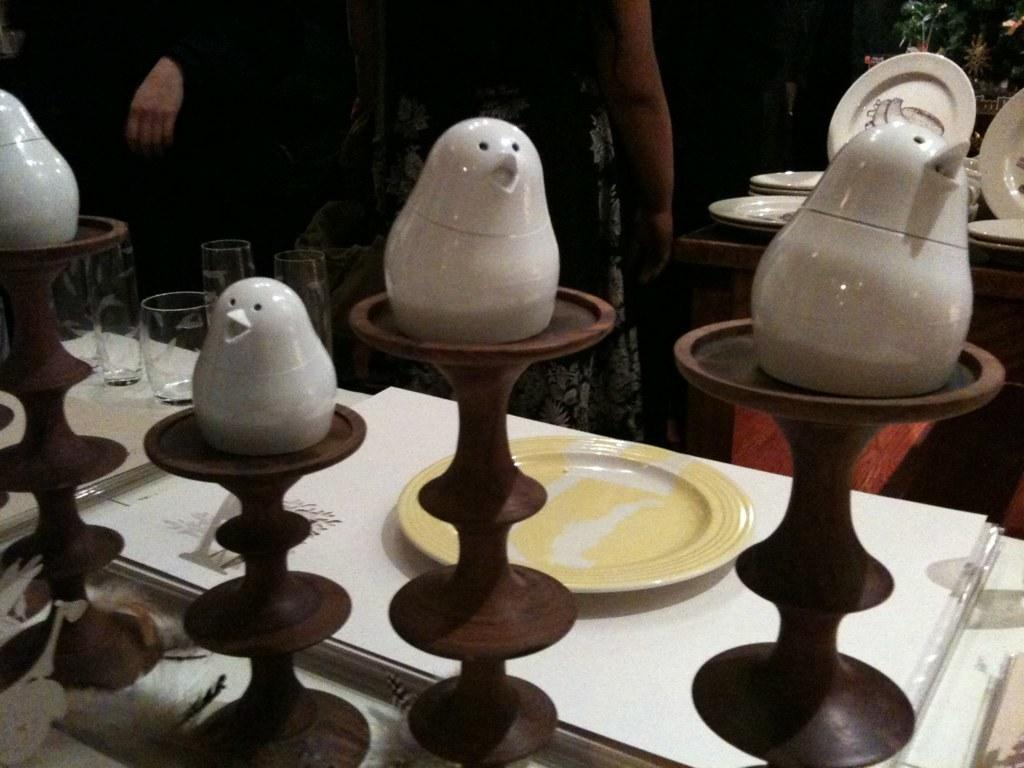What can be seen on the table in the image? There are different objects on the table. Can you describe any specific items on the table? Yes, there are plates and glasses on the table. How does the thread connect the plates and glasses on the table? There is no thread present in the image; it only shows plates and glasses on the table. 